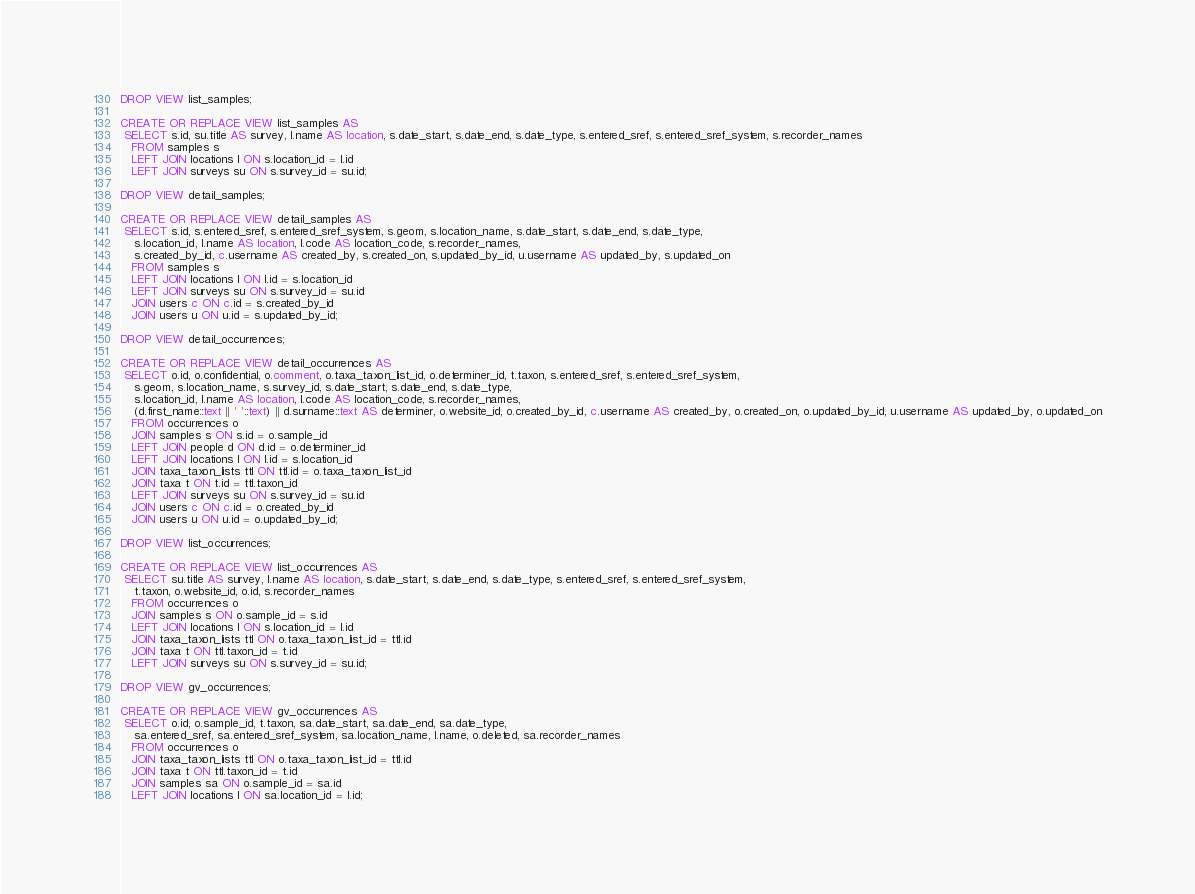<code> <loc_0><loc_0><loc_500><loc_500><_SQL_>DROP VIEW list_samples;

CREATE OR REPLACE VIEW list_samples AS
 SELECT s.id, su.title AS survey, l.name AS location, s.date_start, s.date_end, s.date_type, s.entered_sref, s.entered_sref_system, s.recorder_names
   FROM samples s
   LEFT JOIN locations l ON s.location_id = l.id
   LEFT JOIN surveys su ON s.survey_id = su.id;

DROP VIEW detail_samples;

CREATE OR REPLACE VIEW detail_samples AS
 SELECT s.id, s.entered_sref, s.entered_sref_system, s.geom, s.location_name, s.date_start, s.date_end, s.date_type,
 	s.location_id, l.name AS location, l.code AS location_code, s.recorder_names,
 	s.created_by_id, c.username AS created_by, s.created_on, s.updated_by_id, u.username AS updated_by, s.updated_on
   FROM samples s
   LEFT JOIN locations l ON l.id = s.location_id
   LEFT JOIN surveys su ON s.survey_id = su.id
   JOIN users c ON c.id = s.created_by_id
   JOIN users u ON u.id = s.updated_by_id;

DROP VIEW detail_occurrences;

CREATE OR REPLACE VIEW detail_occurrences AS
 SELECT o.id, o.confidential, o.comment, o.taxa_taxon_list_id, o.determiner_id, t.taxon, s.entered_sref, s.entered_sref_system,
 	s.geom, s.location_name, s.survey_id, s.date_start, s.date_end, s.date_type,
 	s.location_id, l.name AS location, l.code AS location_code, s.recorder_names,
 	(d.first_name::text || ' '::text) || d.surname::text AS determiner, o.website_id, o.created_by_id, c.username AS created_by, o.created_on, o.updated_by_id, u.username AS updated_by, o.updated_on
   FROM occurrences o
   JOIN samples s ON s.id = o.sample_id
   LEFT JOIN people d ON d.id = o.determiner_id
   LEFT JOIN locations l ON l.id = s.location_id
   JOIN taxa_taxon_lists ttl ON ttl.id = o.taxa_taxon_list_id
   JOIN taxa t ON t.id = ttl.taxon_id
   LEFT JOIN surveys su ON s.survey_id = su.id
   JOIN users c ON c.id = o.created_by_id
   JOIN users u ON u.id = o.updated_by_id;

DROP VIEW list_occurrences;

CREATE OR REPLACE VIEW list_occurrences AS
 SELECT su.title AS survey, l.name AS location, s.date_start, s.date_end, s.date_type, s.entered_sref, s.entered_sref_system,
 	t.taxon, o.website_id, o.id, s.recorder_names
   FROM occurrences o
   JOIN samples s ON o.sample_id = s.id
   LEFT JOIN locations l ON s.location_id = l.id
   JOIN taxa_taxon_lists ttl ON o.taxa_taxon_list_id = ttl.id
   JOIN taxa t ON ttl.taxon_id = t.id
   LEFT JOIN surveys su ON s.survey_id = su.id;

DROP VIEW gv_occurrences;

CREATE OR REPLACE VIEW gv_occurrences AS
 SELECT o.id, o.sample_id, t.taxon, sa.date_start, sa.date_end, sa.date_type,
 	sa.entered_sref, sa.entered_sref_system, sa.location_name, l.name, o.deleted, sa.recorder_names
   FROM occurrences o
   JOIN taxa_taxon_lists ttl ON o.taxa_taxon_list_id = ttl.id
   JOIN taxa t ON ttl.taxon_id = t.id
   JOIN samples sa ON o.sample_id = sa.id
   LEFT JOIN locations l ON sa.location_id = l.id;
</code> 